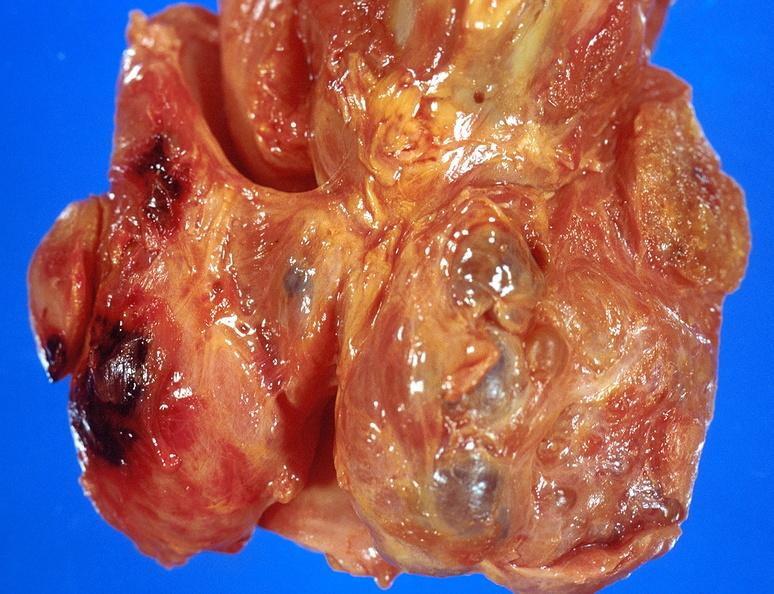what does this image show?
Answer the question using a single word or phrase. Thyroid 